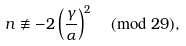<formula> <loc_0><loc_0><loc_500><loc_500>n \not \equiv - 2 \left ( \frac { \gamma } { \alpha } \right ) ^ { 2 } \pmod { 2 9 } ,</formula> 